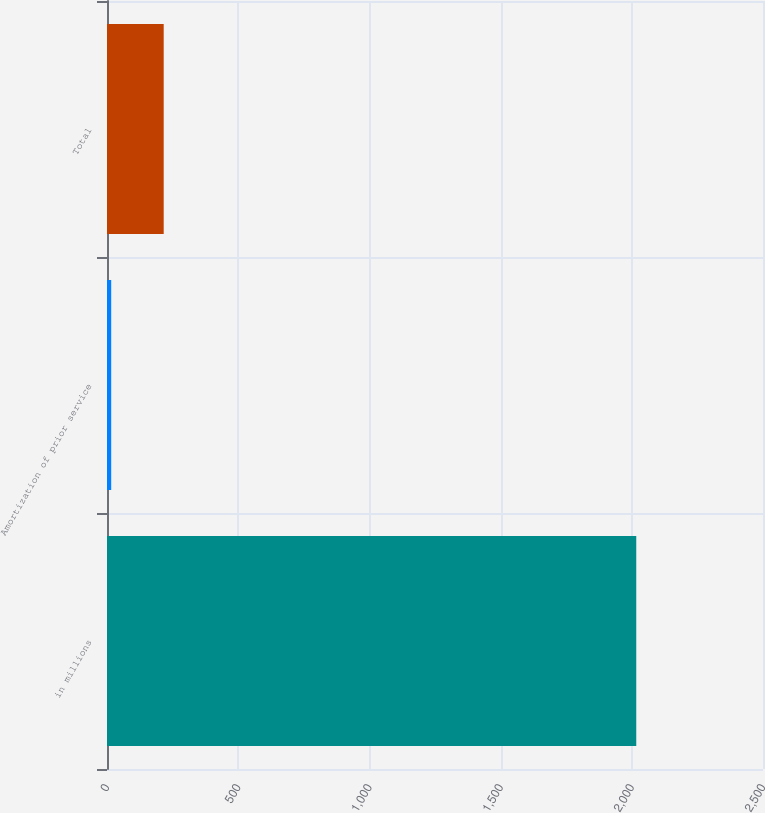<chart> <loc_0><loc_0><loc_500><loc_500><bar_chart><fcel>in millions<fcel>Amortization of prior service<fcel>Total<nl><fcel>2017<fcel>16<fcel>216.1<nl></chart> 